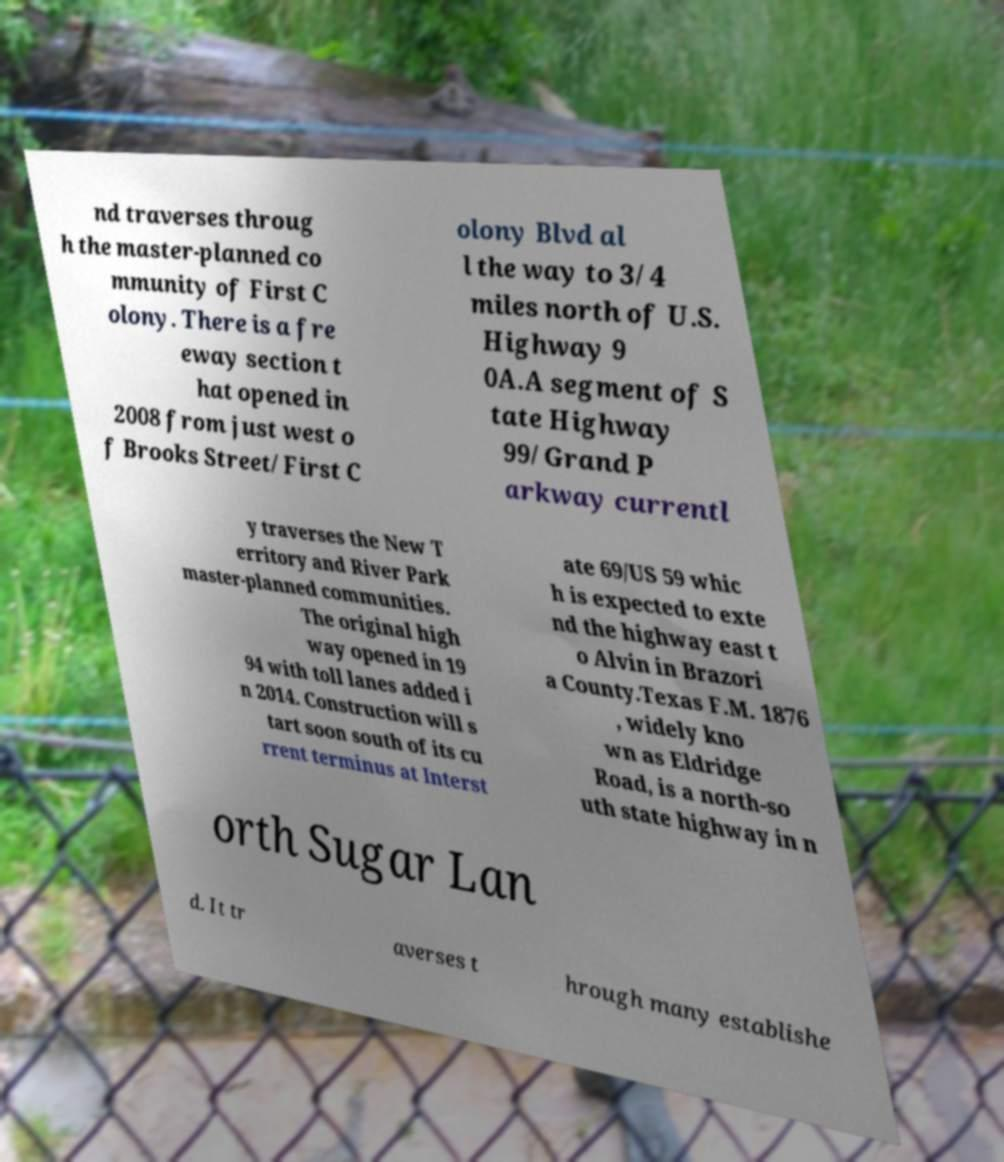Please read and relay the text visible in this image. What does it say? nd traverses throug h the master-planned co mmunity of First C olony. There is a fre eway section t hat opened in 2008 from just west o f Brooks Street/First C olony Blvd al l the way to 3/4 miles north of U.S. Highway 9 0A.A segment of S tate Highway 99/Grand P arkway currentl y traverses the New T erritory and River Park master-planned communities. The original high way opened in 19 94 with toll lanes added i n 2014. Construction will s tart soon south of its cu rrent terminus at Interst ate 69/US 59 whic h is expected to exte nd the highway east t o Alvin in Brazori a County.Texas F.M. 1876 , widely kno wn as Eldridge Road, is a north-so uth state highway in n orth Sugar Lan d. It tr averses t hrough many establishe 